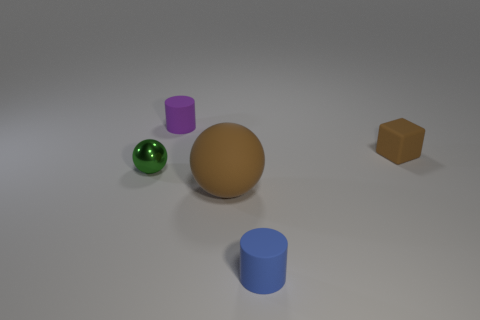Is there anything else that has the same size as the brown matte ball?
Keep it short and to the point. No. What number of small cylinders are right of the big matte sphere and behind the blue object?
Ensure brevity in your answer.  0. How many things are either small rubber objects that are to the right of the purple cylinder or tiny objects left of the tiny block?
Your response must be concise. 4. What number of other objects are there of the same size as the purple matte object?
Ensure brevity in your answer.  3. There is a brown matte thing left of the small thing in front of the small green shiny sphere; what shape is it?
Your response must be concise. Sphere. There is a ball right of the purple matte object; does it have the same color as the tiny rubber object that is to the right of the tiny blue matte thing?
Your response must be concise. Yes. Is there anything else that has the same color as the small shiny object?
Your answer should be compact. No. The big matte sphere has what color?
Provide a short and direct response. Brown. Is there a red matte cube?
Ensure brevity in your answer.  No. There is a small shiny sphere; are there any brown things behind it?
Give a very brief answer. Yes. 